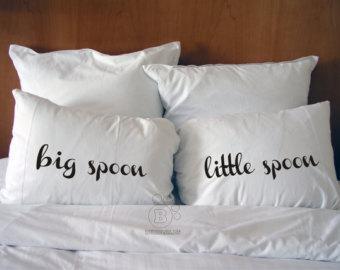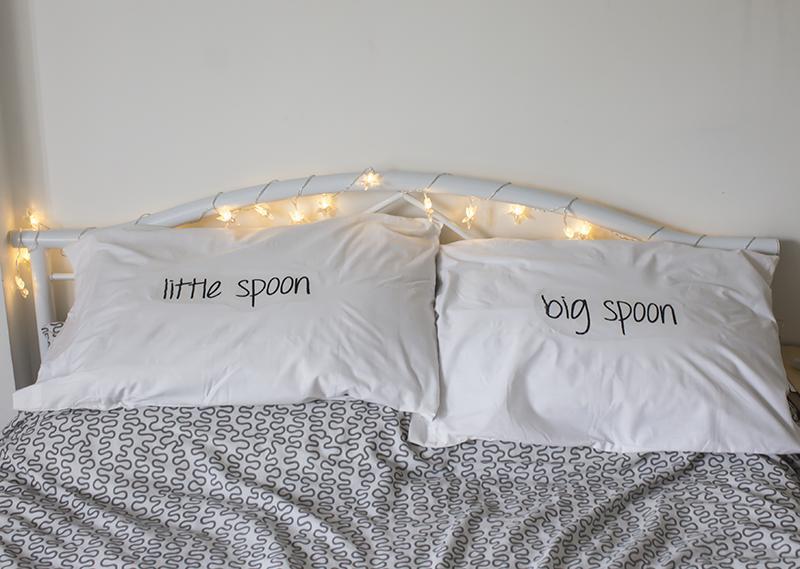The first image is the image on the left, the second image is the image on the right. For the images displayed, is the sentence "A set of pillows features same-style bold all lower-case cursive lettering, while the other set features at least one pillow with non-cursive writing." factually correct? Answer yes or no. Yes. The first image is the image on the left, the second image is the image on the right. Considering the images on both sides, is "There are more pillows in the image on the left than in the image on the right." valid? Answer yes or no. Yes. 